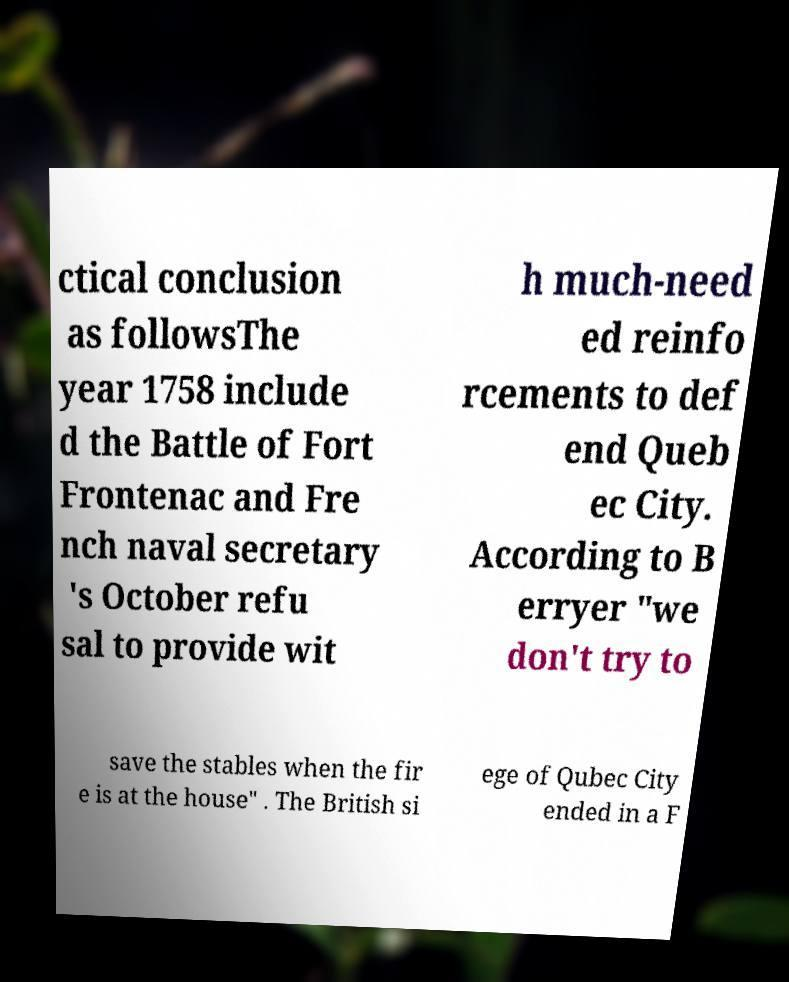For documentation purposes, I need the text within this image transcribed. Could you provide that? ctical conclusion as followsThe year 1758 include d the Battle of Fort Frontenac and Fre nch naval secretary 's October refu sal to provide wit h much-need ed reinfo rcements to def end Queb ec City. According to B erryer "we don't try to save the stables when the fir e is at the house" . The British si ege of Qubec City ended in a F 